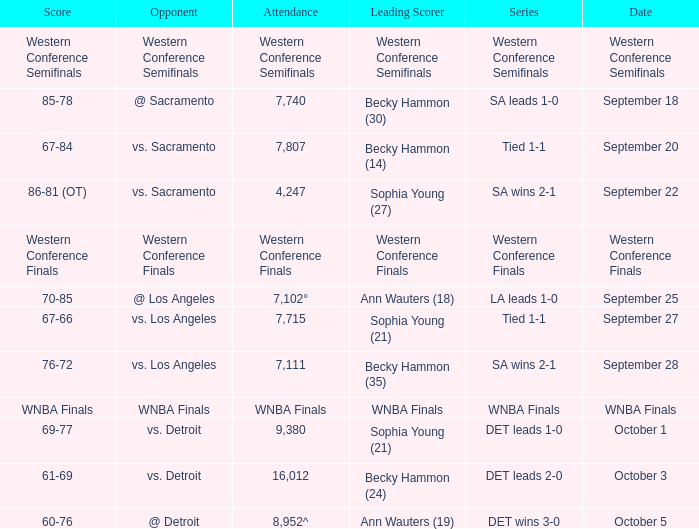Who is the opponent of the game with a tied 1-1 series and becky hammon (14) as the leading scorer? Vs. sacramento. 